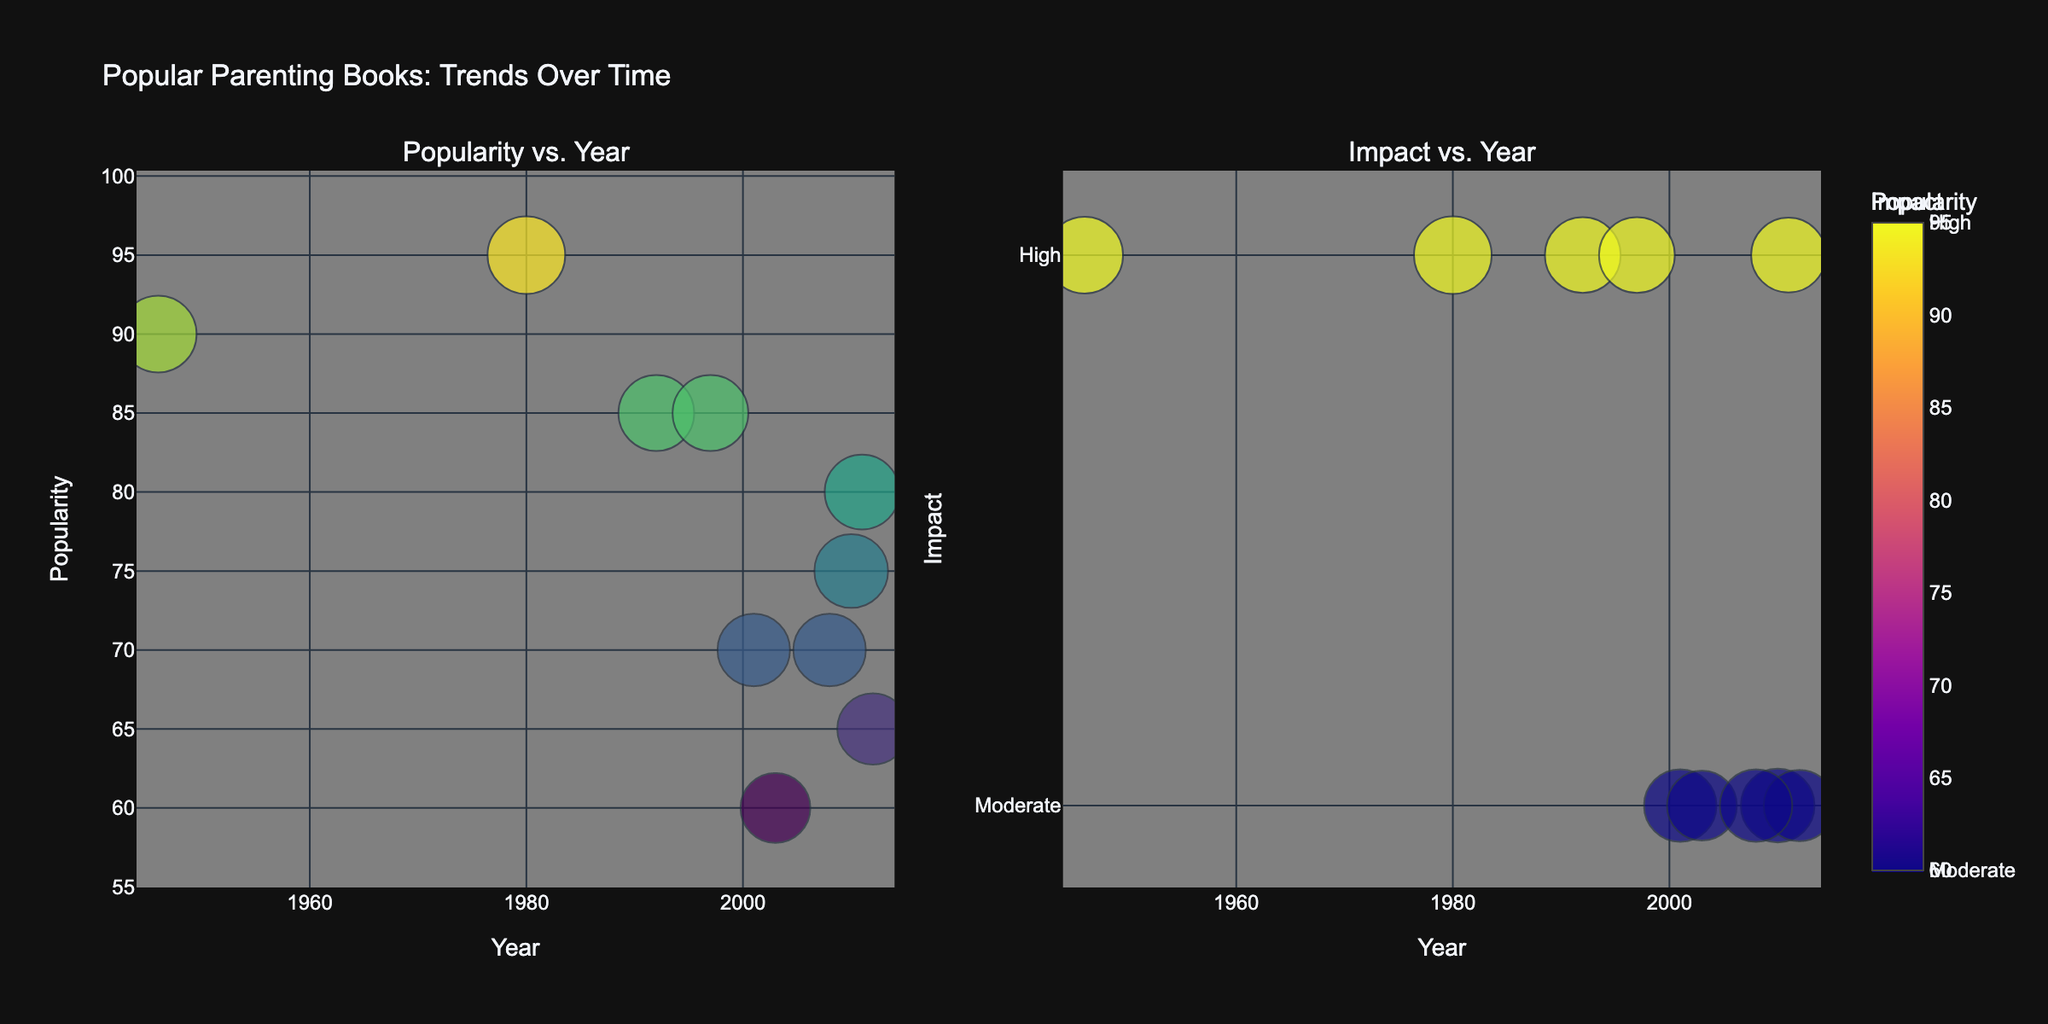What is the title of the figure? The title is typically found at the top center of the figure. In this case, it states: "Popular Parenting Books: Trends Over Time"
Answer: Popular Parenting Books: Trends Over Time How is impact categorized on the right plot? Impact is represented using three categories: Low, Moderate, and High, which are visually distinguished by different marker colors. A colorbar shows the corresponding tick values: 1 (Low), 2 (Moderate), and 3 (High).
Answer: Low, Moderate, High Which book title has the highest popularity? By examining the y-axis marker for popularity on the left subplot, "How to Talk So Kids Will Listen & Listen So Kids Will Talk" has the highest marker position along the y-axis.
Answer: How to Talk So Kids Will Listen & Listen So Kids Will Talk Which year featured the most books? By counting the number of markers along the x-axis, 2012 is the year with the most books, indicated by several data points.
Answer: 2012 Compare the popularity of "The Whole-Brain Child" and "Bringing Up Bébé". Which one is more popular? Locate the markers for these books on the left subplot. "The Whole-Brain Child" is positioned higher on the y-axis compared to "Bringing Up Bébé", indicating it has a higher popularity score.
Answer: The Whole-Brain Child What's the average popularity of books published in the 2010s? Identify books published in the 2010s: "Brain Rules for Baby" (75), "The Whole-Brain Child" (80), and "Bringing Up Bébé" (65). Calculate the average: (75 + 80 + 65) / 3 = 220 / 3 ≈ 73.33
Answer: 73.33 Among books with high impact, which has the lowest popularity? Identify books with a high impact (right subplot's highest color bar marker): "Baby and Child Care", "The Whole-Brain Child", "Touchpoints", "How to Talk So Kids Will Listen & Listen So Kids Will Talk", and "The 5 Love Languages of Children". Of these, "The 5 Love Languages of Children" has the lowest popularity, around 85.
Answer: The 5 Love Languages of Children How does the size of the bubble correlate with popularity? The size of the bubbles increases as the popularity score increases, as indicated by the left subplot’s larger markers corresponding to higher scores in the color scale. This means bubble size is positively correlated with popularity.
Answer: Positively correlated Which theme appears most frequently among the books listed? Below the markers in each subplot, identify the themes: "Health & Development" appears twice. Other themes like "Cognitive Development", "Emotional Intelligence", "Cultural Perspectives", etc., only appear once.
Answer: Health & Development Which book on the right has the highest impact and what year was it published? On the right subplot, the marker with the highest position and intensity in color (indicating the highest impact) is "How to Talk So Kids Will Listen & Listen So Kids Will Talk", published in 1980.
Answer: How to Talk So Kids Will Listen & Listen So Kids Will Talk, 1980 